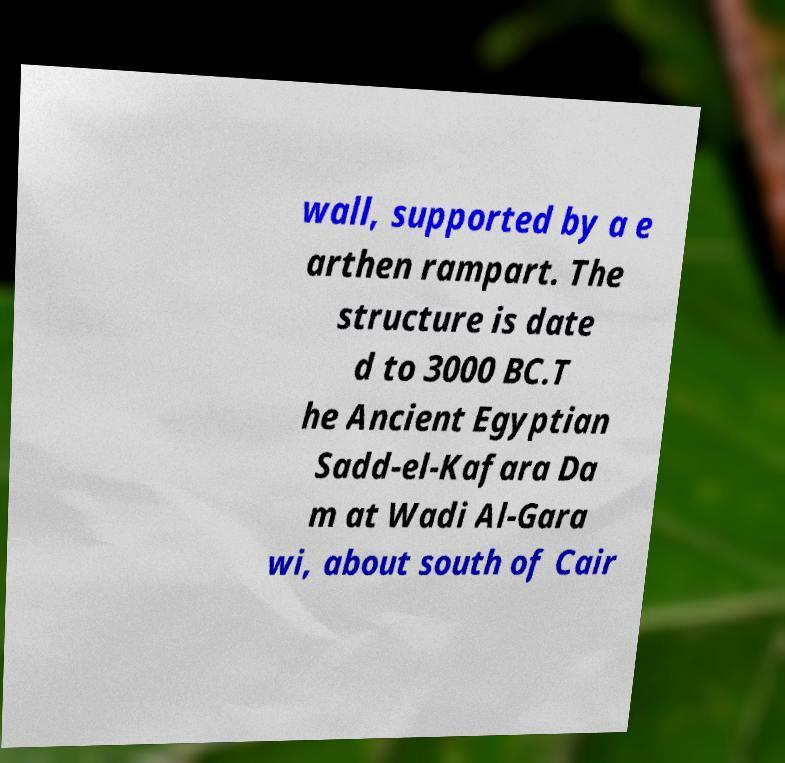Can you read and provide the text displayed in the image?This photo seems to have some interesting text. Can you extract and type it out for me? wall, supported by a e arthen rampart. The structure is date d to 3000 BC.T he Ancient Egyptian Sadd-el-Kafara Da m at Wadi Al-Gara wi, about south of Cair 